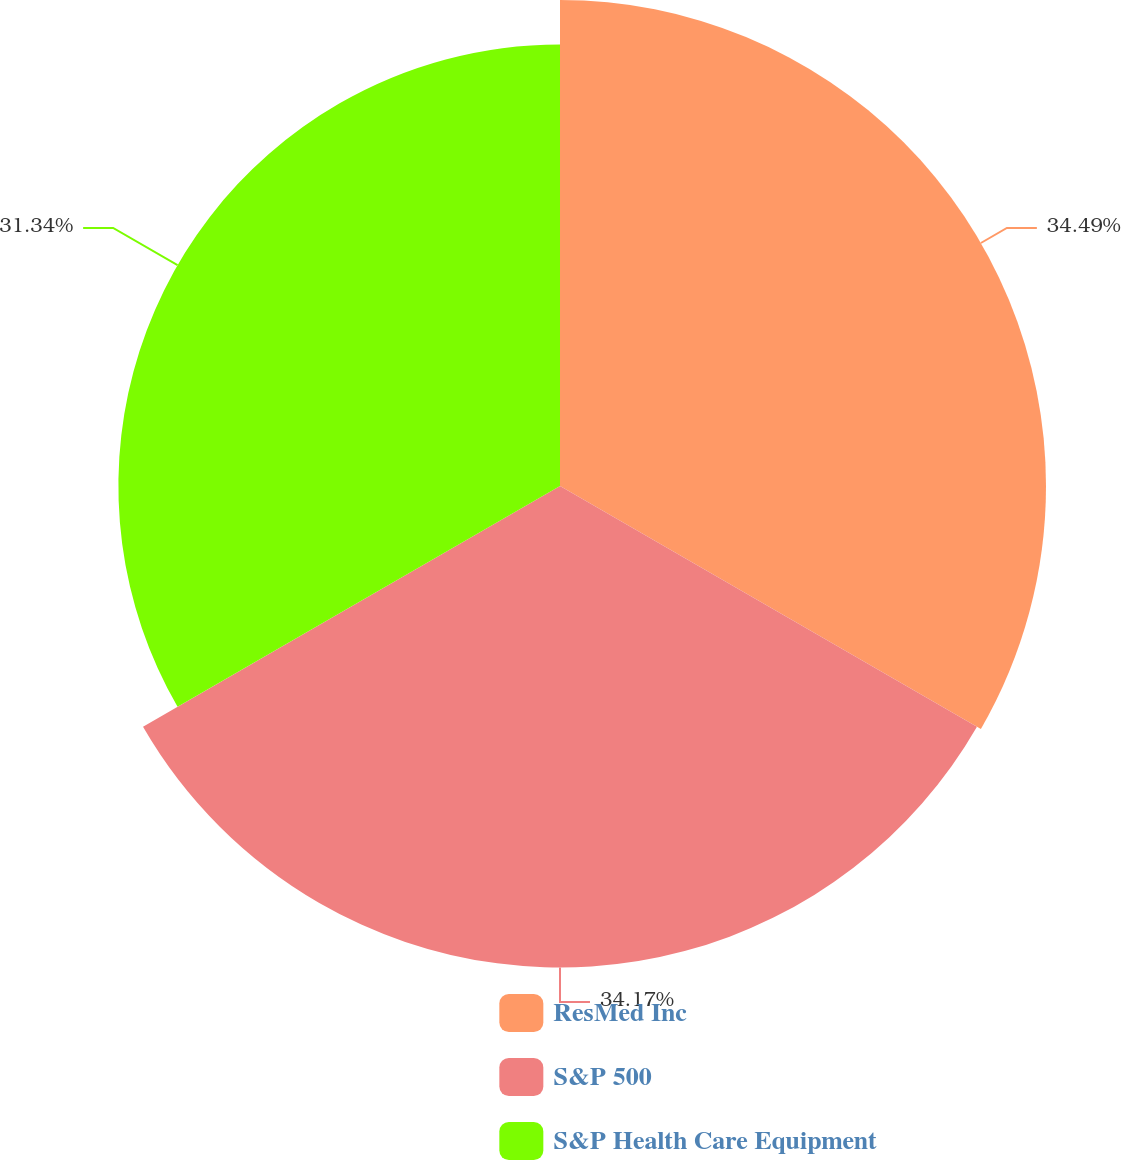<chart> <loc_0><loc_0><loc_500><loc_500><pie_chart><fcel>ResMed Inc<fcel>S&P 500<fcel>S&P Health Care Equipment<nl><fcel>34.49%<fcel>34.17%<fcel>31.34%<nl></chart> 